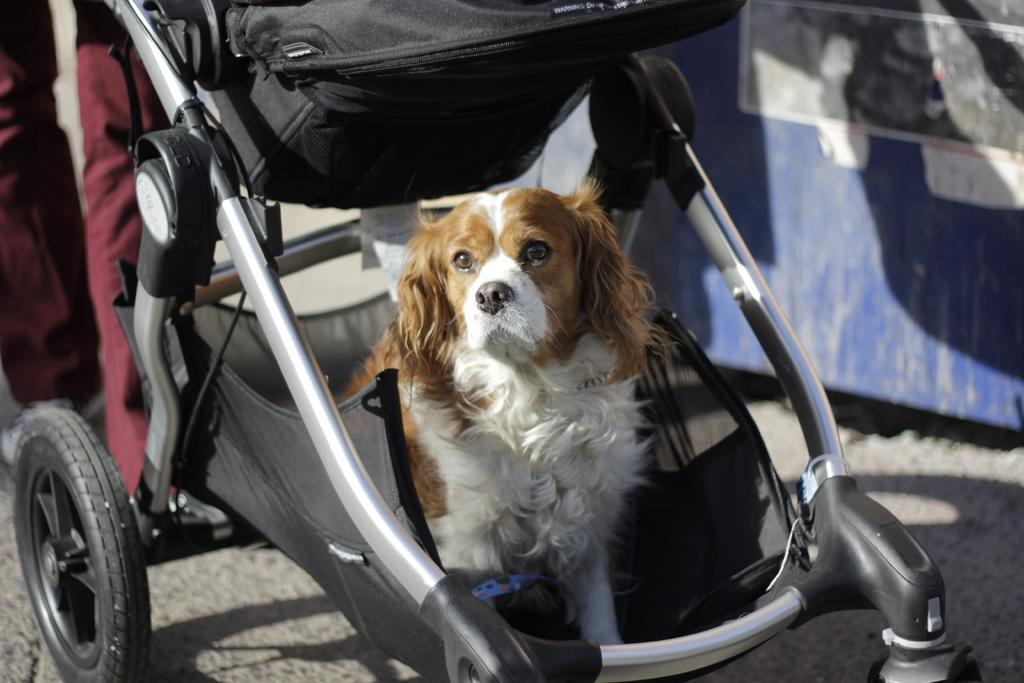What type of animal is in the baby stroller in the image? There is a dog in the baby stroller in the image. Can you describe what is on the left side of the image? There are person legs on the left side of the image. How many ducks are visible in the image? There are no ducks present in the image. What type of expression can be seen on the farmer's face in the image? There is no farmer present in the image. 